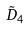<formula> <loc_0><loc_0><loc_500><loc_500>\tilde { D } _ { 4 }</formula> 